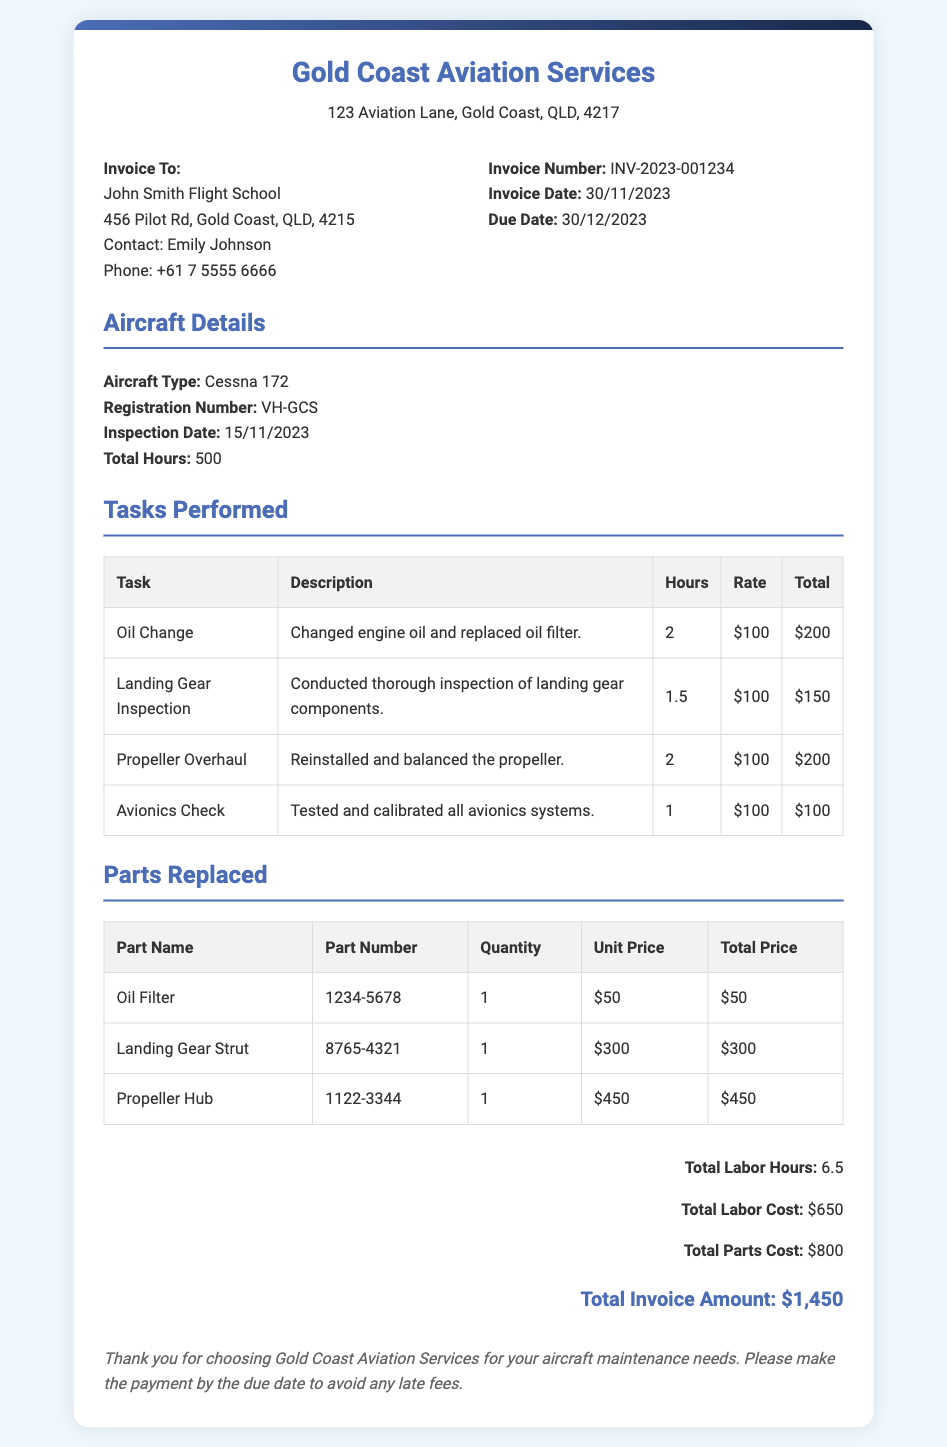What is the invoice number? The invoice number is specified in the document for reference, labeled as "Invoice Number."
Answer: INV-2023-001234 What is the total hours worked on the aircraft? Total hours worked is calculated from the tasks performed, presented in the summary section of the document.
Answer: 6.5 Who is the contact person for the invoice? The document includes contact information for the invoice recipient, giving a specific name under "Contact."
Answer: Emily Johnson What was the total parts cost? The total parts cost is summarized in the document under the "Total Parts Cost" section.
Answer: $800 What is the unit price of the Oil Filter? The unit price of the Oil Filter is detailed in the "Parts Replaced" section against the respective part.
Answer: $50 How much was charged for the Avionics Check? The charge for the Avionics Check can be found in the "Tasks Performed" table, detailing the cost for the specific task.
Answer: $100 What type of aircraft was inspected? The aircraft type is clearly stated in the "Aircraft Details" section of the document.
Answer: Cessna 172 When is the payment due? The due date for payment is mentioned explicitly in the invoice details section.
Answer: 30/12/2023 What task took the longest to complete? The task duration is specified in the "Tasks Performed" table, where the longest task can be identified.
Answer: Oil Change 